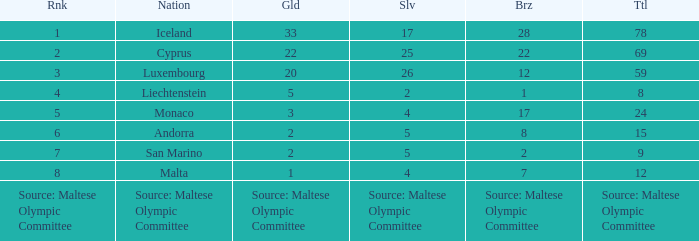What is the count of gold medals when the quantity of bronze medals is 8? 2.0. 